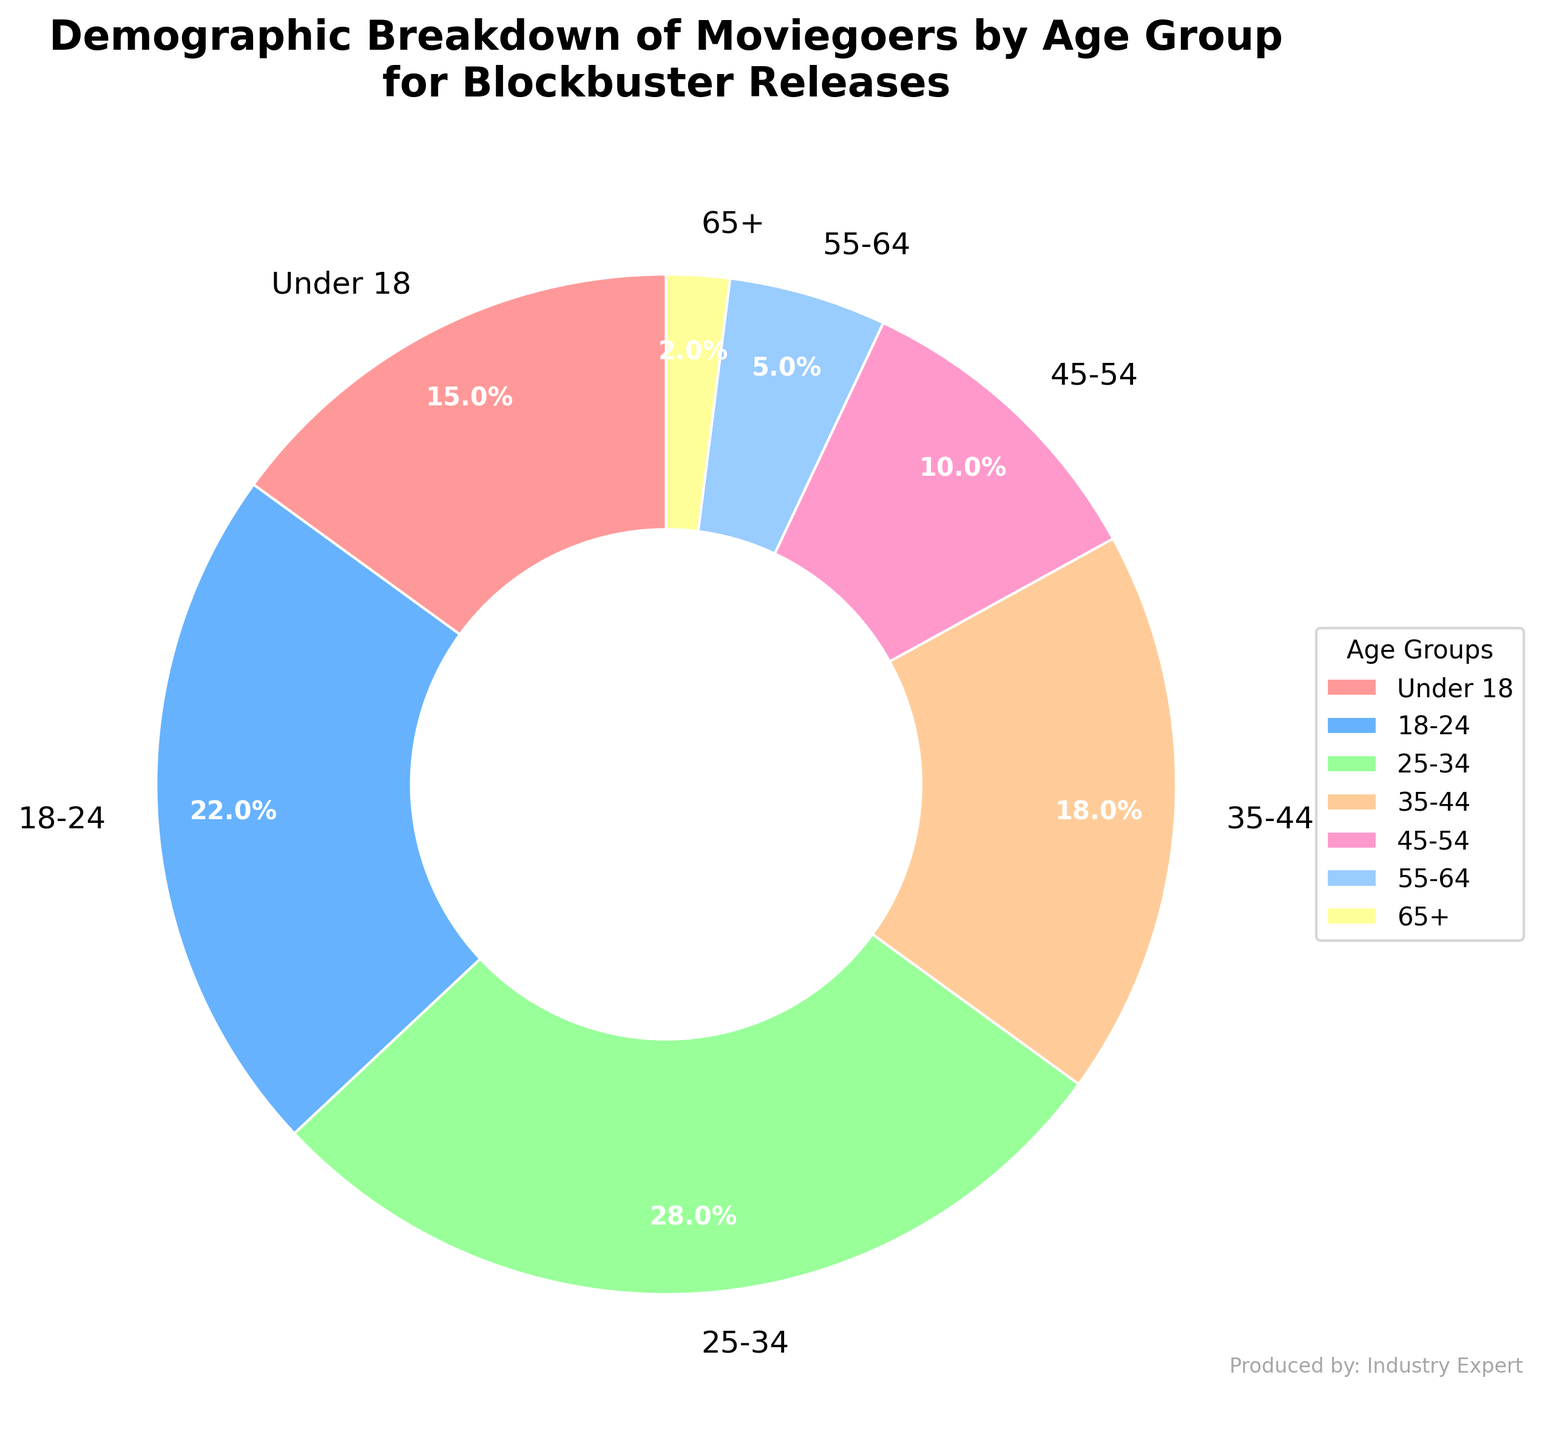What's the percentage of moviegoers under 25 years old? First, identify the age groups that fall under 25 years old: "Under 18" and "18-24". Then, sum up their percentages: 15% + 22%.
Answer: 37% Which age group represents the largest percentage of moviegoers? Look at the pie chart and identify the age group with the largest slice. The "25-34" age group has the largest percentage.
Answer: 25-34 Which two age groups combined make up more than 50% of the moviegoers? Identify the age groups with the largest percentages and sum them up until the total exceeds 50%. The age groups "18-24" (22%) and "25-34" (28%) combined make up 50%. Since this totally is exactly 50%, it doesn't cross 50%. Add the next largest group "35-44" to 50%. Thus, the combined total of "Under 18" kids (15%) and "25-34" age group represents more than 50%.
Answer: Under 18 and 25-34 How does the percentage of moviegoers aged 45-54 compare to those aged 55+? Identify the slices for the "45-54" age group (10%) and the combined percentage for "55-64" (5%) and "65+" (2%), totaling the percentages of the latter two: 5% + 2% = 7%. The "45-54" group has a higher percentage.
Answer: 45-54 has a higher percentage What is the combined percentage of moviegoers over the age of 44? Identify the age groups over 44: "45-54", "55-64", and "65+". Sum the percentages of these groups: 10% + 5% + 2%.
Answer: 17% Which age group has the smallest percentage of moviegoers? Look at the pie chart and identify the age group with the smallest slice, which is "65+" with 2%.
Answer: 65+ What is the total percentage of moviegoers between the ages of 18 and 44? Identify the age groups within this range: "18-24", "25-34", and "35-44". Sum their percentages: 22% + 28% + 18%.
Answer: 68% Which age group has a percentage closest to 20%? Look at the pie chart and find the age group whose percentage is nearest to 20%. The "18-24" group has 22%, which is the closest to 20%.
Answer: 18-24 